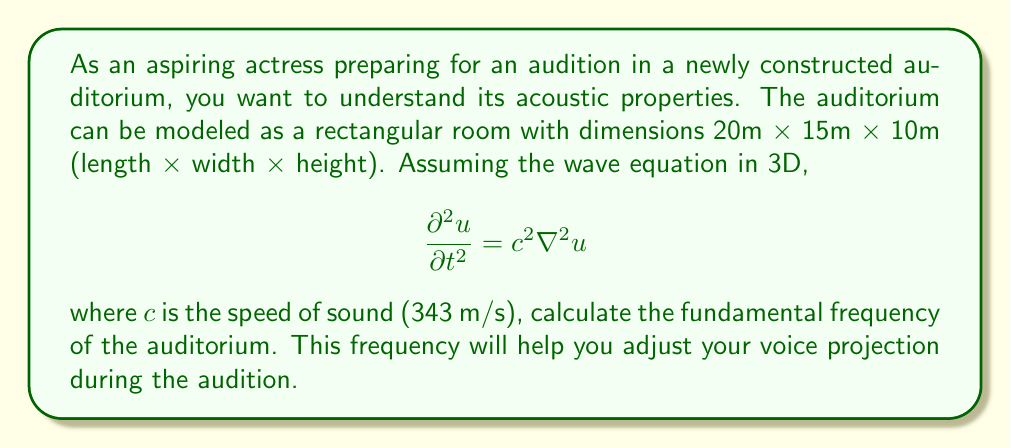Solve this math problem. To solve this problem, we'll follow these steps:

1) The wave equation for a rectangular room with dimensions $L_x$, $L_y$, and $L_z$ has solutions of the form:

   $$u(x,y,z,t) = \sin(\frac{n_x\pi x}{L_x})\sin(\frac{n_y\pi y}{L_y})\sin(\frac{n_z\pi z}{L_z})\cos(\omega t)$$

   where $n_x$, $n_y$, and $n_z$ are positive integers.

2) The corresponding frequencies are given by:

   $$f = \frac{c}{2}\sqrt{(\frac{n_x}{L_x})^2 + (\frac{n_y}{L_y})^2 + (\frac{n_z}{L_z})^2}$$

3) The fundamental frequency occurs when $n_x = n_y = n_z = 1$. Let's substitute our values:

   $L_x = 20$ m, $L_y = 15$ m, $L_z = 10$ m, $c = 343$ m/s

4) Plugging these into our equation:

   $$f = \frac{343}{2}\sqrt{(\frac{1}{20})^2 + (\frac{1}{15})^2 + (\frac{1}{10})^2}$$

5) Simplify under the square root:

   $$f = \frac{343}{2}\sqrt{0.0025 + 0.0044 + 0.01} = \frac{343}{2}\sqrt{0.0169}$$

6) Calculate the final result:

   $$f = 171.5 \cdot 0.13 \approx 22.3 \text{ Hz}$$
Answer: 22.3 Hz 